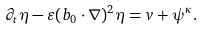Convert formula to latex. <formula><loc_0><loc_0><loc_500><loc_500>\partial _ { t } \eta - \varepsilon ( b _ { 0 } \cdot \nabla ) ^ { 2 } \eta = v + \psi ^ { \kappa } .</formula> 